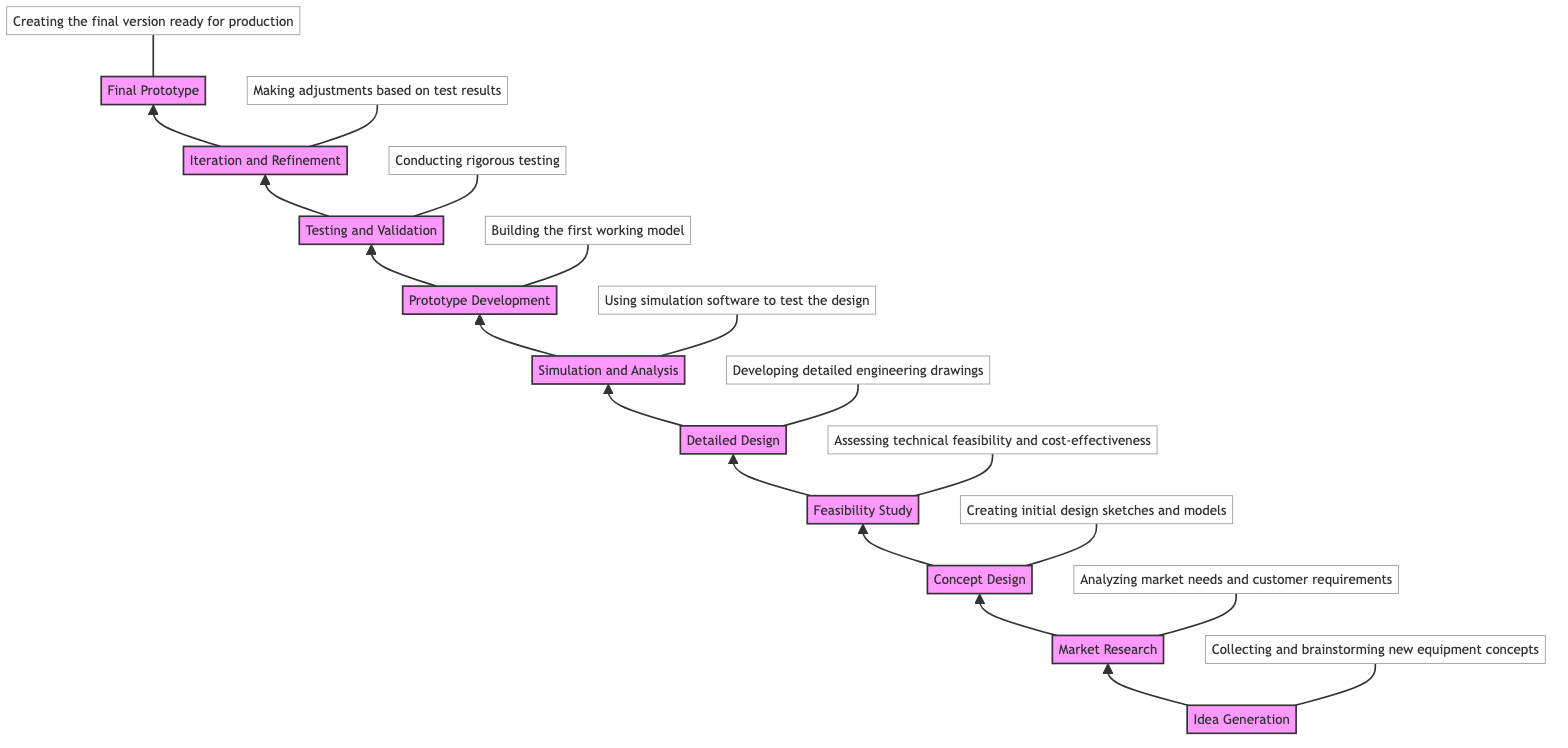What is the first stage in the diagram? The first stage listed in the flowchart is "Idea Generation," which is the initial point of the development process for new manufacturing equipment.
Answer: Idea Generation How many total stages are depicted in the flowchart? By counting the stages from "Idea Generation" to "Final Prototype," there are 10 distinct stages shown in the diagram.
Answer: 10 Which stage comes directly after "Detailed Design"? From the flowchart, "Simulation and Analysis" follows "Detailed Design" as the next stage in the sequence of development.
Answer: Simulation and Analysis What describes the "Testing and Validation" stage? The description for the "Testing and Validation" stage indicates that it involves conducting rigorous testing to ensure the prototype meets all performance, safety, and regulatory standards.
Answer: Conducting rigorous testing Which stage involves adjustments based on test results? The "Iteration and Refinement" stage specifically focuses on making adjustments based on feedback and test results to enhance the prototype's quality.
Answer: Iteration and Refinement At what stage is the first working model of the equipment built? According to the flowchart, the "Prototype Development" stage is where the first working model is constructed based on the design specifications.
Answer: Prototype Development What is the last stage in the flowchart? The last stage in the development process is "Final Prototype," which signifies the completion of the prototype that is ready for production planning.
Answer: Final Prototype What is the immediate preceding stage before "Market Research"? The stage that comes immediately before "Market Research" is "Idea Generation," as it is the foundational stage that leads to research activities.
Answer: Idea Generation Which stages include the use of design-related software? Both the "Concept Design" and "Simulation and Analysis" stages involve the use of software; CAD software is used in the former, while simulation software is utilized in the latter.
Answer: Concept Design, Simulation and Analysis What is the purpose of the "Feasibility Study"? This stage is focused on assessing the technical feasibility, cost-effectiveness, and availability of resources concerning the proposed design improvements.
Answer: Assessing technical feasibility, cost-effectiveness, and resource availability 